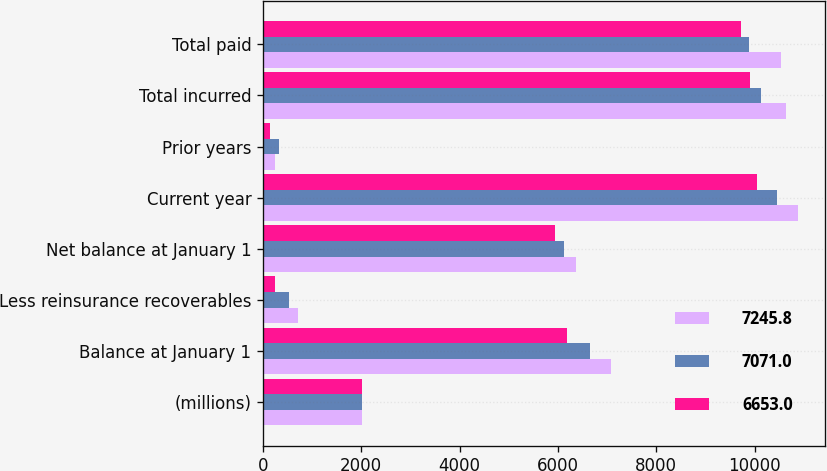Convert chart to OTSL. <chart><loc_0><loc_0><loc_500><loc_500><stacked_bar_chart><ecel><fcel>(millions)<fcel>Balance at January 1<fcel>Less reinsurance recoverables<fcel>Net balance at January 1<fcel>Current year<fcel>Prior years<fcel>Total incurred<fcel>Total paid<nl><fcel>7245.8<fcel>2011<fcel>7071<fcel>704.1<fcel>6366.9<fcel>10876.8<fcel>242<fcel>10634.8<fcel>10541.6<nl><fcel>7071<fcel>2010<fcel>6653<fcel>529.4<fcel>6123.6<fcel>10451.7<fcel>320.4<fcel>10131.3<fcel>9888<nl><fcel>6653<fcel>2009<fcel>6177.4<fcel>244.5<fcel>5932.9<fcel>10040.9<fcel>136<fcel>9904.9<fcel>9714.2<nl></chart> 